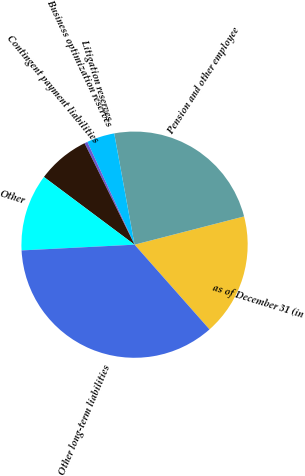Convert chart. <chart><loc_0><loc_0><loc_500><loc_500><pie_chart><fcel>as of December 31 (in<fcel>Pension and other employee<fcel>Litigation reserves<fcel>Business optimization reserves<fcel>Contingent payment liabilities<fcel>Other<fcel>Other long-term liabilities<nl><fcel>17.49%<fcel>23.86%<fcel>3.97%<fcel>0.44%<fcel>7.5%<fcel>11.02%<fcel>35.71%<nl></chart> 